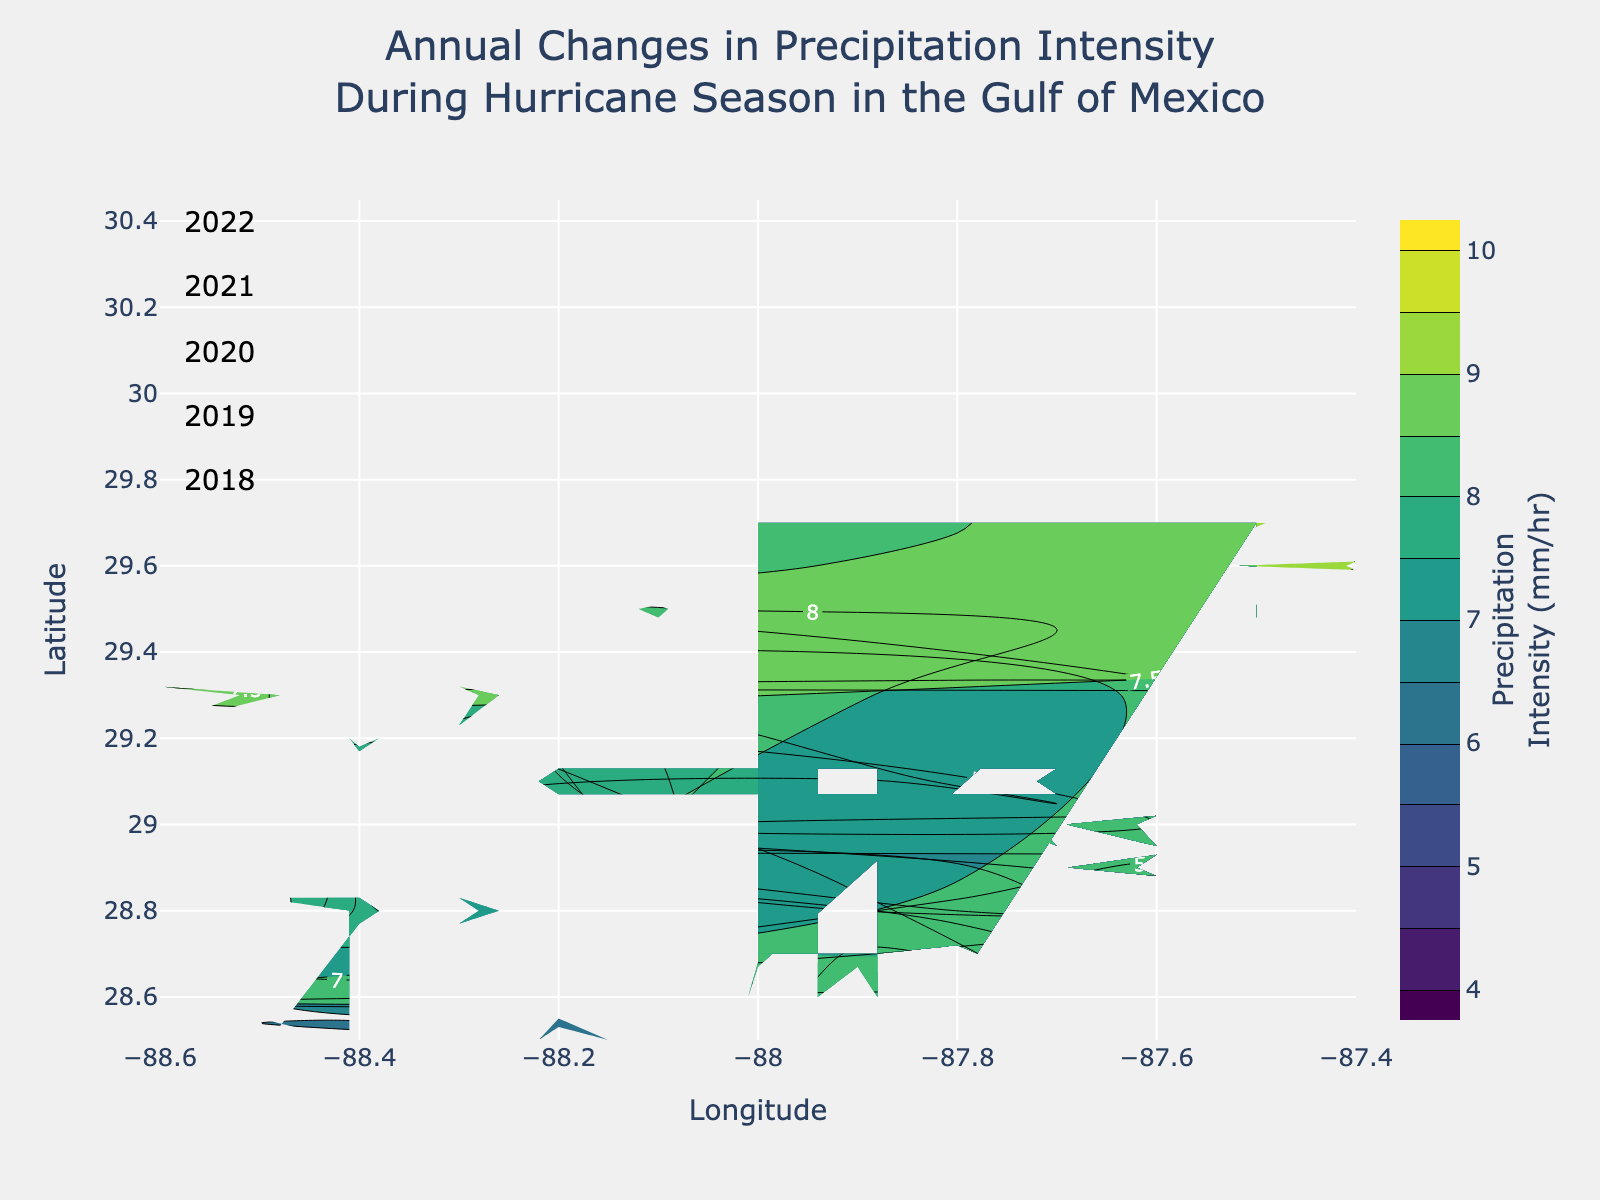What is the title of the plot? The title is clearly displayed at the top of the plot, indicating the focus of the analysis.
Answer: Annual Changes in Precipitation Intensity During Hurricane Season in the Gulf of Mexico What is the color scale used in the contour plot? The color scale determines how precipitation intensity is visually represented; here it ranges from light green to dark blue, as indicated by the colorbar on the right.
Answer: Viridis What are the latitude and longitude ranges covered in the plot? The x-axis shows longitudes ranging from -88.6 to -87.4, while the y-axis shows latitudes ranging from 28.5 to 29.7, as indicated by the axis labels and ticks.
Answer: Longitude: -88.6 to -87.4, Latitude: 28.5 to 29.7 How does the precipitation intensity change from 2018 to 2022? For each year, the contour plot suggests a steady increase in precipitation intensity during hurricane season, with higher intensity values appearing towards more recent years, as shown by the annotations for each year near their respective areas.
Answer: Increases Which region experienced the highest precipitation intensity in 2022? By observing the darkest blue areas in the 2022 region, which corresponds to the highest precipitation levels on the Viridis color scale, we can find the latitude and longitude where the value is highest.
Answer: Around Latitude 29.7 and Longitude -87.4 What is the general trend in precipitation intensity along the latitude from June to October for each year? By examining the contours from top to bottom within each annotated year, there’s an evident pattern where precipitation intensity generally increases, suggesting more intense precipitation as the hurricane season progresses.
Answer: Increasing Compare the precipitation intensity for July across all years; which year had the highest intensity? Looking at the contours for July in each year, the year with the darkest shade of blue represents the highest intensity as per the color scale.
Answer: 2022 How do the values of precipitation intensity vary along longitude at a fixed latitude of 29.0 in September across different years? By fixing the latitude at 29.0 and looking at the contours corresponding to the longitude values particularly in September for each year, we can compare the changes in color intensity.
Answer: Increases as years progress What are the precipitation intensity levels at the coordinates 28.6 latitude and -87.8 longitude in June and October for 2019? To find these values, examine the contours at the specified coordinates for the corresponding months, interpreting the color and label on the contour lines directly.
Answer: June: 5.5 mm/hr, October: 5.0 mm/hr Which latitude-longitude pair experienced the most significant increase in precipitation intensity from 2018 to 2022? Compare the contour labels at various coordinates across all years; the pair with the most significant transition towards darker shades of blue signifies the maximum increase.
Answer: Latitude 29.7, Longitude -87.4 